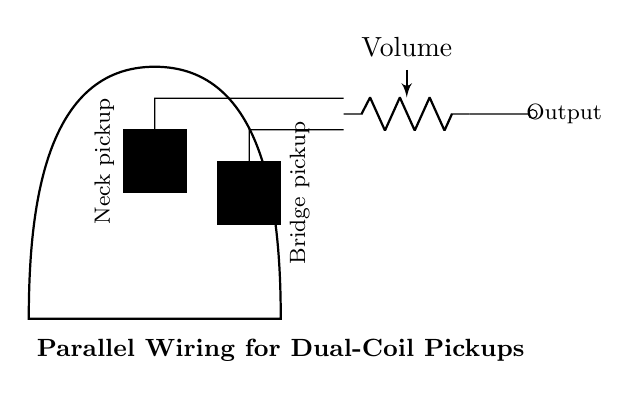What type of wiring configuration is used here? The circuit diagram shows a parallel wiring configuration, indicated by the way the pickups are connected side-by-side to the volume pot.
Answer: parallel How many pickups are shown in the diagram? The diagram includes two rectangular shapes labeled as pickup components, which corresponds to the neck and bridge pickups.
Answer: two What component precedes the output in the circuit? The component that comes before the output jack is the volume pot, which controls the audio signal level before it reaches the output.
Answer: Volume What is the position of the neck pickup in the diagram? The neck pickup is the first rectangle placed towards the left in the circuit diagram, signifying its position on a guitar.
Answer: left What happens to the total resistance when pickups are wired in parallel? When pickups are connected in parallel, the total resistance decreases because parallel resistances combine to create a lower equivalent resistance compared to each individual component.
Answer: decreases How is the output from the pickups sent to the output jack? The output from both pickups is directed towards the output jack via short connections, which merge the signals into a single output path for amplification.
Answer: directly 